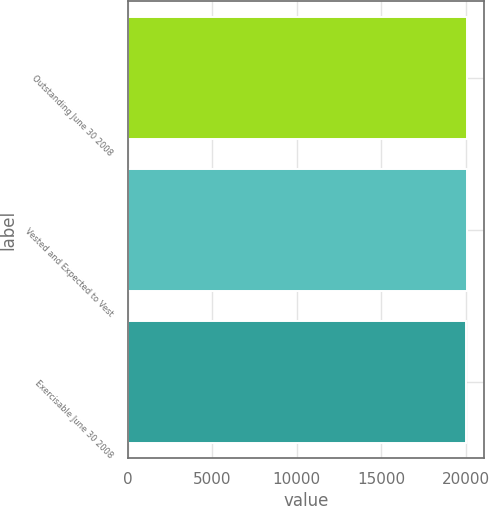Convert chart. <chart><loc_0><loc_0><loc_500><loc_500><bar_chart><fcel>Outstanding June 30 2008<fcel>Vested and Expected to Vest<fcel>Exercisable June 30 2008<nl><fcel>20101<fcel>20105.7<fcel>20054<nl></chart> 